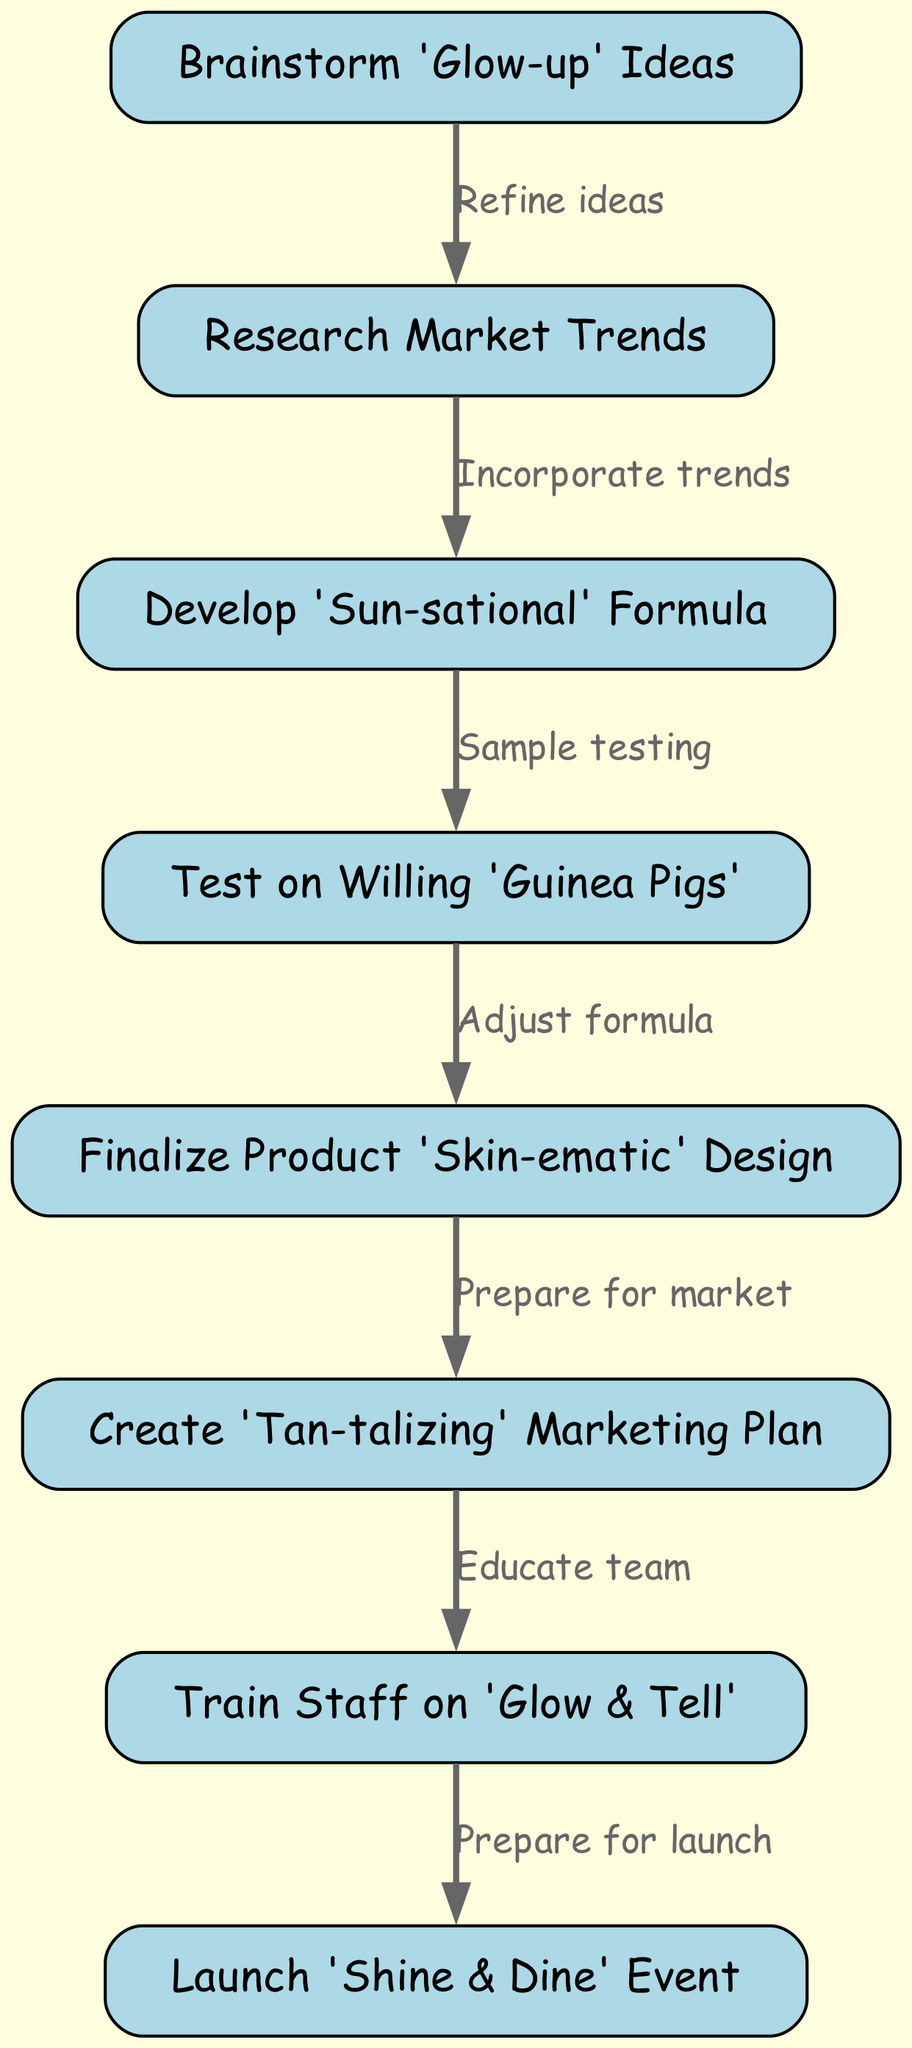What is the first step in the workflow? The workflow begins with "Brainstorm 'Glow-up' Ideas," which is the first node in the diagram.
Answer: Brainstorm 'Glow-up' Ideas How many nodes are in the diagram? By counting every unique step represented in the diagram, there are a total of eight nodes listed for the workflow.
Answer: 8 What is the connection between "Research Market Trends" and "Develop 'Sun-sational' Formula"? "Research Market Trends" leads to "Develop 'Sun-sational' Formula," indicating that trends are incorporated when developing the formula.
Answer: Incorporate trends After testing, what is the next step regarding the product design? After the testing phase ("Test on Willing 'Guinea Pigs'"), the next step is to "Finalize Product 'Skin-ematic' Design" which adjusts the formula following the tests.
Answer: Finalize Product 'Skin-ematic' Design How many edges are there in total in the diagram? Each connection (edge) between the nodes represents a flow in the process, and there are seven edges described in the workflow.
Answer: 7 Which step involves training the staff for the product launch? The step that involves staff training is "Train Staff on 'Glow & Tell'," indicating preparation to convey product benefits.
Answer: Train Staff on 'Glow & Tell' What must happen before the launch event? Before the "Launch 'Shine & Dine' Event," the staff must be trained to ensure they are ready to promote the product effectively.
Answer: Prepare for launch What does "Create 'Tan-talizing' Marketing Plan" follow from? This step follows "Prepare for market," highlighting that the product's design is finalized before developing the marketing strategy.
Answer: Prepare for market 